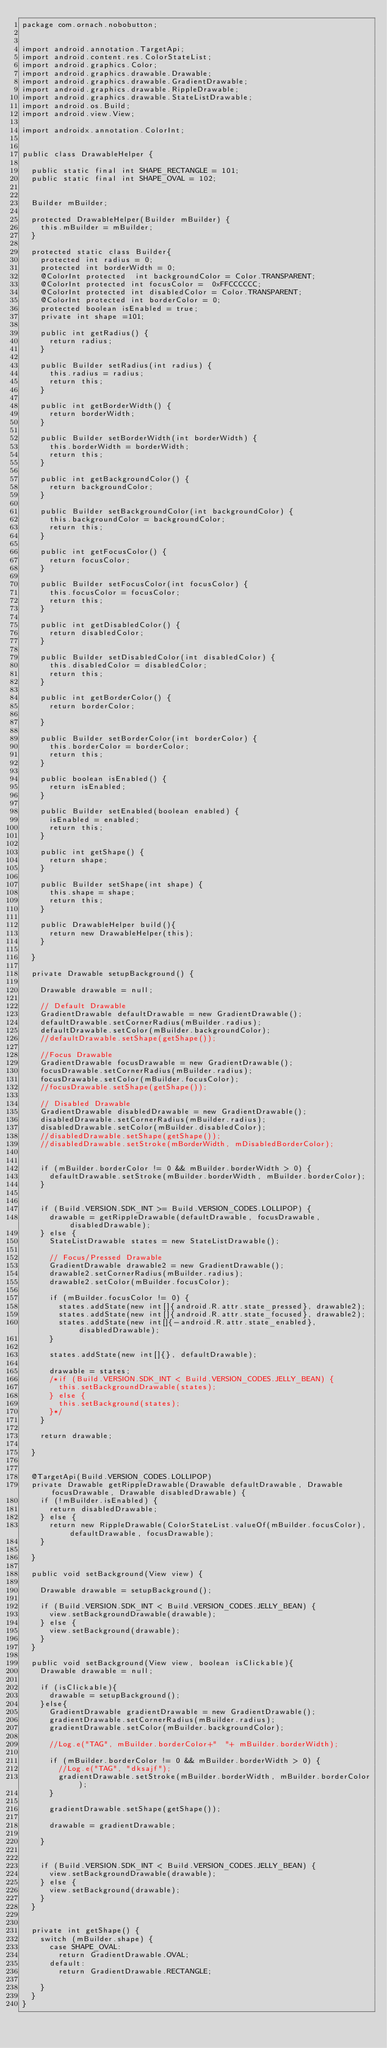<code> <loc_0><loc_0><loc_500><loc_500><_Java_>package com.ornach.nobobutton;


import android.annotation.TargetApi;
import android.content.res.ColorStateList;
import android.graphics.Color;
import android.graphics.drawable.Drawable;
import android.graphics.drawable.GradientDrawable;
import android.graphics.drawable.RippleDrawable;
import android.graphics.drawable.StateListDrawable;
import android.os.Build;
import android.view.View;

import androidx.annotation.ColorInt;


public class DrawableHelper {

	public static final int SHAPE_RECTANGLE = 101;
	public static final int SHAPE_OVAL = 102;


	Builder mBuilder;

	protected DrawableHelper(Builder mBuilder) {
		this.mBuilder = mBuilder;
	}

	protected static class Builder{
		protected int radius = 0;
		protected int borderWidth = 0;
		@ColorInt protected  int backgroundColor = Color.TRANSPARENT;
		@ColorInt protected int focusColor =  0xFFCCCCCC;
		@ColorInt protected int disabledColor = Color.TRANSPARENT;
		@ColorInt protected int borderColor = 0;
		protected boolean isEnabled = true;
		private int shape =101;

		public int getRadius() {
			return radius;
		}

		public Builder setRadius(int radius) {
			this.radius = radius;
			return this;
		}

		public int getBorderWidth() {
			return borderWidth;
		}

		public Builder setBorderWidth(int borderWidth) {
			this.borderWidth = borderWidth;
			return this;
		}

		public int getBackgroundColor() {
			return backgroundColor;
		}

		public Builder setBackgroundColor(int backgroundColor) {
			this.backgroundColor = backgroundColor;
			return this;
		}

		public int getFocusColor() {
			return focusColor;
		}

		public Builder setFocusColor(int focusColor) {
			this.focusColor = focusColor;
			return this;
		}

		public int getDisabledColor() {
			return disabledColor;
		}

		public Builder setDisabledColor(int disabledColor) {
			this.disabledColor = disabledColor;
			return this;
		}

		public int getBorderColor() {
			return borderColor;

		}

		public Builder setBorderColor(int borderColor) {
			this.borderColor = borderColor;
			return this;
		}

		public boolean isEnabled() {
			return isEnabled;
		}

		public Builder setEnabled(boolean enabled) {
			isEnabled = enabled;
			return this;
		}

		public int getShape() {
			return shape;
		}

		public Builder setShape(int shape) {
			this.shape = shape;
			return this;
		}

		public DrawableHelper build(){
			return new DrawableHelper(this);
		}

	}

	private Drawable setupBackground() {

		Drawable drawable = null;

		// Default Drawable
		GradientDrawable defaultDrawable = new GradientDrawable();
		defaultDrawable.setCornerRadius(mBuilder.radius);
		defaultDrawable.setColor(mBuilder.backgroundColor);
		//defaultDrawable.setShape(getShape());

		//Focus Drawable
		GradientDrawable focusDrawable = new GradientDrawable();
		focusDrawable.setCornerRadius(mBuilder.radius);
		focusDrawable.setColor(mBuilder.focusColor);
		//focusDrawable.setShape(getShape());

		// Disabled Drawable
		GradientDrawable disabledDrawable = new GradientDrawable();
		disabledDrawable.setCornerRadius(mBuilder.radius);
		disabledDrawable.setColor(mBuilder.disabledColor);
		//disabledDrawable.setShape(getShape());
		//disabledDrawable.setStroke(mBorderWidth, mDisabledBorderColor);


		if (mBuilder.borderColor != 0 && mBuilder.borderWidth > 0) {
			defaultDrawable.setStroke(mBuilder.borderWidth, mBuilder.borderColor);
		}


		if (Build.VERSION.SDK_INT >= Build.VERSION_CODES.LOLLIPOP) {
			drawable = getRippleDrawable(defaultDrawable, focusDrawable, disabledDrawable);
		} else {
			StateListDrawable states = new StateListDrawable();

			// Focus/Pressed Drawable
			GradientDrawable drawable2 = new GradientDrawable();
			drawable2.setCornerRadius(mBuilder.radius);
			drawable2.setColor(mBuilder.focusColor);

			if (mBuilder.focusColor != 0) {
				states.addState(new int[]{android.R.attr.state_pressed}, drawable2);
				states.addState(new int[]{android.R.attr.state_focused}, drawable2);
				states.addState(new int[]{-android.R.attr.state_enabled}, disabledDrawable);
			}

			states.addState(new int[]{}, defaultDrawable);

			drawable = states;
			/*if (Build.VERSION.SDK_INT < Build.VERSION_CODES.JELLY_BEAN) {
				this.setBackgroundDrawable(states);
			} else {
				this.setBackground(states);
			}*/
		}

		return drawable;

	}


	@TargetApi(Build.VERSION_CODES.LOLLIPOP)
	private Drawable getRippleDrawable(Drawable defaultDrawable, Drawable focusDrawable, Drawable disabledDrawable) {
		if (!mBuilder.isEnabled) {
			return disabledDrawable;
		} else {
			return new RippleDrawable(ColorStateList.valueOf(mBuilder.focusColor), defaultDrawable, focusDrawable);
		}

	}

	public void setBackground(View view) {

		Drawable drawable = setupBackground();

		if (Build.VERSION.SDK_INT < Build.VERSION_CODES.JELLY_BEAN) {
			view.setBackgroundDrawable(drawable);
		} else {
			view.setBackground(drawable);
		}
	}

	public void setBackground(View view, boolean isClickable){
		Drawable drawable = null;

		if (isClickable){
			drawable = setupBackground();
		}else{
			GradientDrawable gradientDrawable = new GradientDrawable();
			gradientDrawable.setCornerRadius(mBuilder.radius);
			gradientDrawable.setColor(mBuilder.backgroundColor);

			//Log.e("TAG", mBuilder.borderColor+"  "+ mBuilder.borderWidth);

			if (mBuilder.borderColor != 0 && mBuilder.borderWidth > 0) {
				//Log.e("TAG", "dksajf");
				gradientDrawable.setStroke(mBuilder.borderWidth, mBuilder.borderColor);
			}

			gradientDrawable.setShape(getShape());

			drawable = gradientDrawable;

		}


		if (Build.VERSION.SDK_INT < Build.VERSION_CODES.JELLY_BEAN) {
			view.setBackgroundDrawable(drawable);
		} else {
			view.setBackground(drawable);
		}
	}


	private int getShape() {
		switch (mBuilder.shape) {
			case SHAPE_OVAL:
				return GradientDrawable.OVAL;
			default:
				return GradientDrawable.RECTANGLE;

		}
	}
}
</code> 